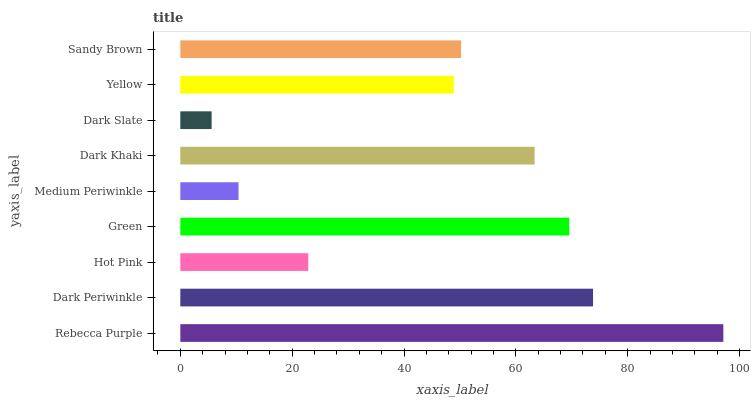Is Dark Slate the minimum?
Answer yes or no. Yes. Is Rebecca Purple the maximum?
Answer yes or no. Yes. Is Dark Periwinkle the minimum?
Answer yes or no. No. Is Dark Periwinkle the maximum?
Answer yes or no. No. Is Rebecca Purple greater than Dark Periwinkle?
Answer yes or no. Yes. Is Dark Periwinkle less than Rebecca Purple?
Answer yes or no. Yes. Is Dark Periwinkle greater than Rebecca Purple?
Answer yes or no. No. Is Rebecca Purple less than Dark Periwinkle?
Answer yes or no. No. Is Sandy Brown the high median?
Answer yes or no. Yes. Is Sandy Brown the low median?
Answer yes or no. Yes. Is Green the high median?
Answer yes or no. No. Is Rebecca Purple the low median?
Answer yes or no. No. 